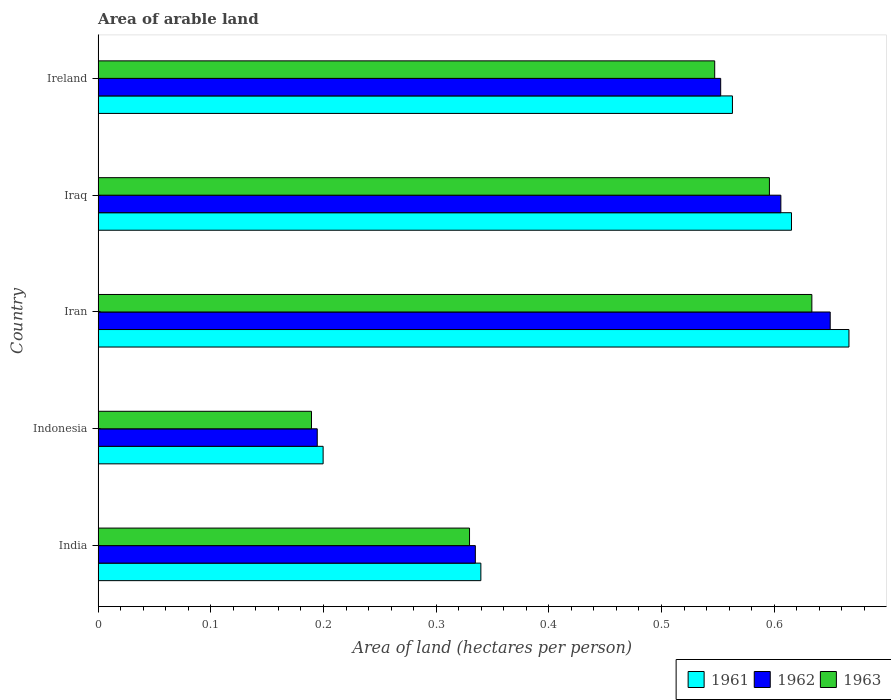How many different coloured bars are there?
Offer a very short reply. 3. How many groups of bars are there?
Ensure brevity in your answer.  5. Are the number of bars per tick equal to the number of legend labels?
Offer a very short reply. Yes. Are the number of bars on each tick of the Y-axis equal?
Your answer should be compact. Yes. How many bars are there on the 3rd tick from the top?
Your answer should be compact. 3. What is the label of the 2nd group of bars from the top?
Provide a short and direct response. Iraq. In how many cases, is the number of bars for a given country not equal to the number of legend labels?
Provide a short and direct response. 0. What is the total arable land in 1962 in Iraq?
Your answer should be very brief. 0.61. Across all countries, what is the maximum total arable land in 1962?
Ensure brevity in your answer.  0.65. Across all countries, what is the minimum total arable land in 1961?
Keep it short and to the point. 0.2. In which country was the total arable land in 1963 maximum?
Offer a very short reply. Iran. What is the total total arable land in 1962 in the graph?
Your response must be concise. 2.34. What is the difference between the total arable land in 1961 in Indonesia and that in Ireland?
Offer a very short reply. -0.36. What is the difference between the total arable land in 1961 in India and the total arable land in 1963 in Iraq?
Give a very brief answer. -0.26. What is the average total arable land in 1961 per country?
Provide a succinct answer. 0.48. What is the difference between the total arable land in 1963 and total arable land in 1961 in Iraq?
Provide a succinct answer. -0.02. In how many countries, is the total arable land in 1963 greater than 0.2 hectares per person?
Ensure brevity in your answer.  4. What is the ratio of the total arable land in 1961 in India to that in Indonesia?
Your answer should be very brief. 1.7. Is the total arable land in 1963 in India less than that in Iraq?
Provide a short and direct response. Yes. Is the difference between the total arable land in 1963 in Iran and Ireland greater than the difference between the total arable land in 1961 in Iran and Ireland?
Keep it short and to the point. No. What is the difference between the highest and the second highest total arable land in 1961?
Your response must be concise. 0.05. What is the difference between the highest and the lowest total arable land in 1962?
Your answer should be very brief. 0.46. Is the sum of the total arable land in 1961 in Iran and Iraq greater than the maximum total arable land in 1962 across all countries?
Offer a terse response. Yes. What does the 3rd bar from the top in Ireland represents?
Provide a succinct answer. 1961. What does the 3rd bar from the bottom in India represents?
Make the answer very short. 1963. How many countries are there in the graph?
Give a very brief answer. 5. Are the values on the major ticks of X-axis written in scientific E-notation?
Your answer should be very brief. No. Does the graph contain any zero values?
Give a very brief answer. No. Does the graph contain grids?
Provide a succinct answer. No. How many legend labels are there?
Provide a short and direct response. 3. How are the legend labels stacked?
Offer a very short reply. Horizontal. What is the title of the graph?
Your answer should be very brief. Area of arable land. Does "1965" appear as one of the legend labels in the graph?
Offer a very short reply. No. What is the label or title of the X-axis?
Provide a short and direct response. Area of land (hectares per person). What is the Area of land (hectares per person) of 1961 in India?
Provide a succinct answer. 0.34. What is the Area of land (hectares per person) of 1962 in India?
Offer a very short reply. 0.33. What is the Area of land (hectares per person) in 1963 in India?
Your answer should be very brief. 0.33. What is the Area of land (hectares per person) in 1961 in Indonesia?
Make the answer very short. 0.2. What is the Area of land (hectares per person) in 1962 in Indonesia?
Your response must be concise. 0.19. What is the Area of land (hectares per person) in 1963 in Indonesia?
Provide a succinct answer. 0.19. What is the Area of land (hectares per person) of 1961 in Iran?
Provide a short and direct response. 0.67. What is the Area of land (hectares per person) in 1962 in Iran?
Keep it short and to the point. 0.65. What is the Area of land (hectares per person) in 1963 in Iran?
Provide a short and direct response. 0.63. What is the Area of land (hectares per person) of 1961 in Iraq?
Offer a terse response. 0.62. What is the Area of land (hectares per person) in 1962 in Iraq?
Keep it short and to the point. 0.61. What is the Area of land (hectares per person) in 1963 in Iraq?
Ensure brevity in your answer.  0.6. What is the Area of land (hectares per person) in 1961 in Ireland?
Your response must be concise. 0.56. What is the Area of land (hectares per person) in 1962 in Ireland?
Ensure brevity in your answer.  0.55. What is the Area of land (hectares per person) of 1963 in Ireland?
Give a very brief answer. 0.55. Across all countries, what is the maximum Area of land (hectares per person) of 1961?
Provide a short and direct response. 0.67. Across all countries, what is the maximum Area of land (hectares per person) in 1962?
Offer a terse response. 0.65. Across all countries, what is the maximum Area of land (hectares per person) in 1963?
Your answer should be compact. 0.63. Across all countries, what is the minimum Area of land (hectares per person) in 1961?
Your answer should be compact. 0.2. Across all countries, what is the minimum Area of land (hectares per person) of 1962?
Your answer should be compact. 0.19. Across all countries, what is the minimum Area of land (hectares per person) of 1963?
Your answer should be very brief. 0.19. What is the total Area of land (hectares per person) in 1961 in the graph?
Make the answer very short. 2.38. What is the total Area of land (hectares per person) of 1962 in the graph?
Ensure brevity in your answer.  2.34. What is the total Area of land (hectares per person) in 1963 in the graph?
Offer a terse response. 2.3. What is the difference between the Area of land (hectares per person) in 1961 in India and that in Indonesia?
Your answer should be very brief. 0.14. What is the difference between the Area of land (hectares per person) of 1962 in India and that in Indonesia?
Ensure brevity in your answer.  0.14. What is the difference between the Area of land (hectares per person) in 1963 in India and that in Indonesia?
Give a very brief answer. 0.14. What is the difference between the Area of land (hectares per person) of 1961 in India and that in Iran?
Make the answer very short. -0.33. What is the difference between the Area of land (hectares per person) in 1962 in India and that in Iran?
Your answer should be compact. -0.31. What is the difference between the Area of land (hectares per person) of 1963 in India and that in Iran?
Your answer should be very brief. -0.3. What is the difference between the Area of land (hectares per person) of 1961 in India and that in Iraq?
Offer a very short reply. -0.28. What is the difference between the Area of land (hectares per person) in 1962 in India and that in Iraq?
Offer a very short reply. -0.27. What is the difference between the Area of land (hectares per person) in 1963 in India and that in Iraq?
Offer a very short reply. -0.27. What is the difference between the Area of land (hectares per person) in 1961 in India and that in Ireland?
Give a very brief answer. -0.22. What is the difference between the Area of land (hectares per person) of 1962 in India and that in Ireland?
Ensure brevity in your answer.  -0.22. What is the difference between the Area of land (hectares per person) of 1963 in India and that in Ireland?
Provide a short and direct response. -0.22. What is the difference between the Area of land (hectares per person) in 1961 in Indonesia and that in Iran?
Ensure brevity in your answer.  -0.47. What is the difference between the Area of land (hectares per person) of 1962 in Indonesia and that in Iran?
Your answer should be compact. -0.46. What is the difference between the Area of land (hectares per person) of 1963 in Indonesia and that in Iran?
Your response must be concise. -0.44. What is the difference between the Area of land (hectares per person) in 1961 in Indonesia and that in Iraq?
Ensure brevity in your answer.  -0.42. What is the difference between the Area of land (hectares per person) of 1962 in Indonesia and that in Iraq?
Your answer should be compact. -0.41. What is the difference between the Area of land (hectares per person) in 1963 in Indonesia and that in Iraq?
Your answer should be very brief. -0.41. What is the difference between the Area of land (hectares per person) of 1961 in Indonesia and that in Ireland?
Ensure brevity in your answer.  -0.36. What is the difference between the Area of land (hectares per person) in 1962 in Indonesia and that in Ireland?
Keep it short and to the point. -0.36. What is the difference between the Area of land (hectares per person) of 1963 in Indonesia and that in Ireland?
Your response must be concise. -0.36. What is the difference between the Area of land (hectares per person) of 1961 in Iran and that in Iraq?
Provide a short and direct response. 0.05. What is the difference between the Area of land (hectares per person) of 1962 in Iran and that in Iraq?
Ensure brevity in your answer.  0.04. What is the difference between the Area of land (hectares per person) in 1963 in Iran and that in Iraq?
Offer a terse response. 0.04. What is the difference between the Area of land (hectares per person) in 1961 in Iran and that in Ireland?
Offer a terse response. 0.1. What is the difference between the Area of land (hectares per person) of 1962 in Iran and that in Ireland?
Make the answer very short. 0.1. What is the difference between the Area of land (hectares per person) in 1963 in Iran and that in Ireland?
Offer a very short reply. 0.09. What is the difference between the Area of land (hectares per person) of 1961 in Iraq and that in Ireland?
Make the answer very short. 0.05. What is the difference between the Area of land (hectares per person) of 1962 in Iraq and that in Ireland?
Offer a very short reply. 0.05. What is the difference between the Area of land (hectares per person) of 1963 in Iraq and that in Ireland?
Ensure brevity in your answer.  0.05. What is the difference between the Area of land (hectares per person) in 1961 in India and the Area of land (hectares per person) in 1962 in Indonesia?
Offer a very short reply. 0.15. What is the difference between the Area of land (hectares per person) of 1961 in India and the Area of land (hectares per person) of 1963 in Indonesia?
Your answer should be compact. 0.15. What is the difference between the Area of land (hectares per person) of 1962 in India and the Area of land (hectares per person) of 1963 in Indonesia?
Give a very brief answer. 0.15. What is the difference between the Area of land (hectares per person) in 1961 in India and the Area of land (hectares per person) in 1962 in Iran?
Make the answer very short. -0.31. What is the difference between the Area of land (hectares per person) of 1961 in India and the Area of land (hectares per person) of 1963 in Iran?
Offer a very short reply. -0.29. What is the difference between the Area of land (hectares per person) in 1962 in India and the Area of land (hectares per person) in 1963 in Iran?
Provide a succinct answer. -0.3. What is the difference between the Area of land (hectares per person) in 1961 in India and the Area of land (hectares per person) in 1962 in Iraq?
Offer a terse response. -0.27. What is the difference between the Area of land (hectares per person) of 1961 in India and the Area of land (hectares per person) of 1963 in Iraq?
Your answer should be very brief. -0.26. What is the difference between the Area of land (hectares per person) of 1962 in India and the Area of land (hectares per person) of 1963 in Iraq?
Ensure brevity in your answer.  -0.26. What is the difference between the Area of land (hectares per person) in 1961 in India and the Area of land (hectares per person) in 1962 in Ireland?
Your response must be concise. -0.21. What is the difference between the Area of land (hectares per person) in 1961 in India and the Area of land (hectares per person) in 1963 in Ireland?
Your response must be concise. -0.21. What is the difference between the Area of land (hectares per person) in 1962 in India and the Area of land (hectares per person) in 1963 in Ireland?
Provide a short and direct response. -0.21. What is the difference between the Area of land (hectares per person) in 1961 in Indonesia and the Area of land (hectares per person) in 1962 in Iran?
Your answer should be very brief. -0.45. What is the difference between the Area of land (hectares per person) in 1961 in Indonesia and the Area of land (hectares per person) in 1963 in Iran?
Offer a terse response. -0.43. What is the difference between the Area of land (hectares per person) of 1962 in Indonesia and the Area of land (hectares per person) of 1963 in Iran?
Provide a short and direct response. -0.44. What is the difference between the Area of land (hectares per person) in 1961 in Indonesia and the Area of land (hectares per person) in 1962 in Iraq?
Make the answer very short. -0.41. What is the difference between the Area of land (hectares per person) of 1961 in Indonesia and the Area of land (hectares per person) of 1963 in Iraq?
Your response must be concise. -0.4. What is the difference between the Area of land (hectares per person) of 1962 in Indonesia and the Area of land (hectares per person) of 1963 in Iraq?
Provide a succinct answer. -0.4. What is the difference between the Area of land (hectares per person) of 1961 in Indonesia and the Area of land (hectares per person) of 1962 in Ireland?
Offer a very short reply. -0.35. What is the difference between the Area of land (hectares per person) of 1961 in Indonesia and the Area of land (hectares per person) of 1963 in Ireland?
Your answer should be very brief. -0.35. What is the difference between the Area of land (hectares per person) in 1962 in Indonesia and the Area of land (hectares per person) in 1963 in Ireland?
Your answer should be very brief. -0.35. What is the difference between the Area of land (hectares per person) in 1961 in Iran and the Area of land (hectares per person) in 1962 in Iraq?
Ensure brevity in your answer.  0.06. What is the difference between the Area of land (hectares per person) of 1961 in Iran and the Area of land (hectares per person) of 1963 in Iraq?
Provide a short and direct response. 0.07. What is the difference between the Area of land (hectares per person) in 1962 in Iran and the Area of land (hectares per person) in 1963 in Iraq?
Keep it short and to the point. 0.05. What is the difference between the Area of land (hectares per person) of 1961 in Iran and the Area of land (hectares per person) of 1962 in Ireland?
Your answer should be compact. 0.11. What is the difference between the Area of land (hectares per person) in 1961 in Iran and the Area of land (hectares per person) in 1963 in Ireland?
Provide a short and direct response. 0.12. What is the difference between the Area of land (hectares per person) in 1962 in Iran and the Area of land (hectares per person) in 1963 in Ireland?
Provide a short and direct response. 0.1. What is the difference between the Area of land (hectares per person) of 1961 in Iraq and the Area of land (hectares per person) of 1962 in Ireland?
Keep it short and to the point. 0.06. What is the difference between the Area of land (hectares per person) in 1961 in Iraq and the Area of land (hectares per person) in 1963 in Ireland?
Offer a very short reply. 0.07. What is the difference between the Area of land (hectares per person) in 1962 in Iraq and the Area of land (hectares per person) in 1963 in Ireland?
Offer a terse response. 0.06. What is the average Area of land (hectares per person) of 1961 per country?
Provide a short and direct response. 0.48. What is the average Area of land (hectares per person) in 1962 per country?
Ensure brevity in your answer.  0.47. What is the average Area of land (hectares per person) in 1963 per country?
Provide a short and direct response. 0.46. What is the difference between the Area of land (hectares per person) of 1961 and Area of land (hectares per person) of 1962 in India?
Your answer should be very brief. 0. What is the difference between the Area of land (hectares per person) of 1961 and Area of land (hectares per person) of 1963 in India?
Give a very brief answer. 0.01. What is the difference between the Area of land (hectares per person) in 1962 and Area of land (hectares per person) in 1963 in India?
Provide a succinct answer. 0.01. What is the difference between the Area of land (hectares per person) of 1961 and Area of land (hectares per person) of 1962 in Indonesia?
Offer a terse response. 0.01. What is the difference between the Area of land (hectares per person) in 1961 and Area of land (hectares per person) in 1963 in Indonesia?
Offer a very short reply. 0.01. What is the difference between the Area of land (hectares per person) of 1962 and Area of land (hectares per person) of 1963 in Indonesia?
Ensure brevity in your answer.  0.01. What is the difference between the Area of land (hectares per person) of 1961 and Area of land (hectares per person) of 1962 in Iran?
Make the answer very short. 0.02. What is the difference between the Area of land (hectares per person) in 1961 and Area of land (hectares per person) in 1963 in Iran?
Ensure brevity in your answer.  0.03. What is the difference between the Area of land (hectares per person) in 1962 and Area of land (hectares per person) in 1963 in Iran?
Your response must be concise. 0.02. What is the difference between the Area of land (hectares per person) of 1961 and Area of land (hectares per person) of 1962 in Iraq?
Provide a short and direct response. 0.01. What is the difference between the Area of land (hectares per person) in 1961 and Area of land (hectares per person) in 1963 in Iraq?
Provide a succinct answer. 0.02. What is the difference between the Area of land (hectares per person) of 1962 and Area of land (hectares per person) of 1963 in Iraq?
Provide a succinct answer. 0.01. What is the difference between the Area of land (hectares per person) in 1961 and Area of land (hectares per person) in 1962 in Ireland?
Keep it short and to the point. 0.01. What is the difference between the Area of land (hectares per person) in 1961 and Area of land (hectares per person) in 1963 in Ireland?
Your response must be concise. 0.02. What is the difference between the Area of land (hectares per person) of 1962 and Area of land (hectares per person) of 1963 in Ireland?
Your answer should be compact. 0.01. What is the ratio of the Area of land (hectares per person) of 1961 in India to that in Indonesia?
Provide a succinct answer. 1.7. What is the ratio of the Area of land (hectares per person) in 1962 in India to that in Indonesia?
Provide a short and direct response. 1.72. What is the ratio of the Area of land (hectares per person) of 1963 in India to that in Indonesia?
Ensure brevity in your answer.  1.74. What is the ratio of the Area of land (hectares per person) of 1961 in India to that in Iran?
Give a very brief answer. 0.51. What is the ratio of the Area of land (hectares per person) in 1962 in India to that in Iran?
Your answer should be very brief. 0.52. What is the ratio of the Area of land (hectares per person) of 1963 in India to that in Iran?
Offer a very short reply. 0.52. What is the ratio of the Area of land (hectares per person) in 1961 in India to that in Iraq?
Ensure brevity in your answer.  0.55. What is the ratio of the Area of land (hectares per person) in 1962 in India to that in Iraq?
Provide a succinct answer. 0.55. What is the ratio of the Area of land (hectares per person) of 1963 in India to that in Iraq?
Your answer should be very brief. 0.55. What is the ratio of the Area of land (hectares per person) of 1961 in India to that in Ireland?
Your response must be concise. 0.6. What is the ratio of the Area of land (hectares per person) of 1962 in India to that in Ireland?
Ensure brevity in your answer.  0.61. What is the ratio of the Area of land (hectares per person) of 1963 in India to that in Ireland?
Keep it short and to the point. 0.6. What is the ratio of the Area of land (hectares per person) in 1961 in Indonesia to that in Iran?
Give a very brief answer. 0.3. What is the ratio of the Area of land (hectares per person) of 1962 in Indonesia to that in Iran?
Offer a terse response. 0.3. What is the ratio of the Area of land (hectares per person) in 1963 in Indonesia to that in Iran?
Your answer should be compact. 0.3. What is the ratio of the Area of land (hectares per person) of 1961 in Indonesia to that in Iraq?
Give a very brief answer. 0.32. What is the ratio of the Area of land (hectares per person) of 1962 in Indonesia to that in Iraq?
Provide a short and direct response. 0.32. What is the ratio of the Area of land (hectares per person) in 1963 in Indonesia to that in Iraq?
Offer a very short reply. 0.32. What is the ratio of the Area of land (hectares per person) in 1961 in Indonesia to that in Ireland?
Your answer should be very brief. 0.35. What is the ratio of the Area of land (hectares per person) in 1962 in Indonesia to that in Ireland?
Your answer should be very brief. 0.35. What is the ratio of the Area of land (hectares per person) in 1963 in Indonesia to that in Ireland?
Provide a short and direct response. 0.35. What is the ratio of the Area of land (hectares per person) of 1961 in Iran to that in Iraq?
Ensure brevity in your answer.  1.08. What is the ratio of the Area of land (hectares per person) of 1962 in Iran to that in Iraq?
Ensure brevity in your answer.  1.07. What is the ratio of the Area of land (hectares per person) of 1963 in Iran to that in Iraq?
Provide a succinct answer. 1.06. What is the ratio of the Area of land (hectares per person) in 1961 in Iran to that in Ireland?
Offer a very short reply. 1.18. What is the ratio of the Area of land (hectares per person) of 1962 in Iran to that in Ireland?
Your response must be concise. 1.18. What is the ratio of the Area of land (hectares per person) in 1963 in Iran to that in Ireland?
Give a very brief answer. 1.16. What is the ratio of the Area of land (hectares per person) in 1961 in Iraq to that in Ireland?
Your answer should be very brief. 1.09. What is the ratio of the Area of land (hectares per person) in 1962 in Iraq to that in Ireland?
Keep it short and to the point. 1.1. What is the ratio of the Area of land (hectares per person) of 1963 in Iraq to that in Ireland?
Your response must be concise. 1.09. What is the difference between the highest and the second highest Area of land (hectares per person) of 1961?
Provide a succinct answer. 0.05. What is the difference between the highest and the second highest Area of land (hectares per person) of 1962?
Offer a terse response. 0.04. What is the difference between the highest and the second highest Area of land (hectares per person) in 1963?
Provide a succinct answer. 0.04. What is the difference between the highest and the lowest Area of land (hectares per person) in 1961?
Provide a succinct answer. 0.47. What is the difference between the highest and the lowest Area of land (hectares per person) in 1962?
Provide a short and direct response. 0.46. What is the difference between the highest and the lowest Area of land (hectares per person) in 1963?
Provide a succinct answer. 0.44. 